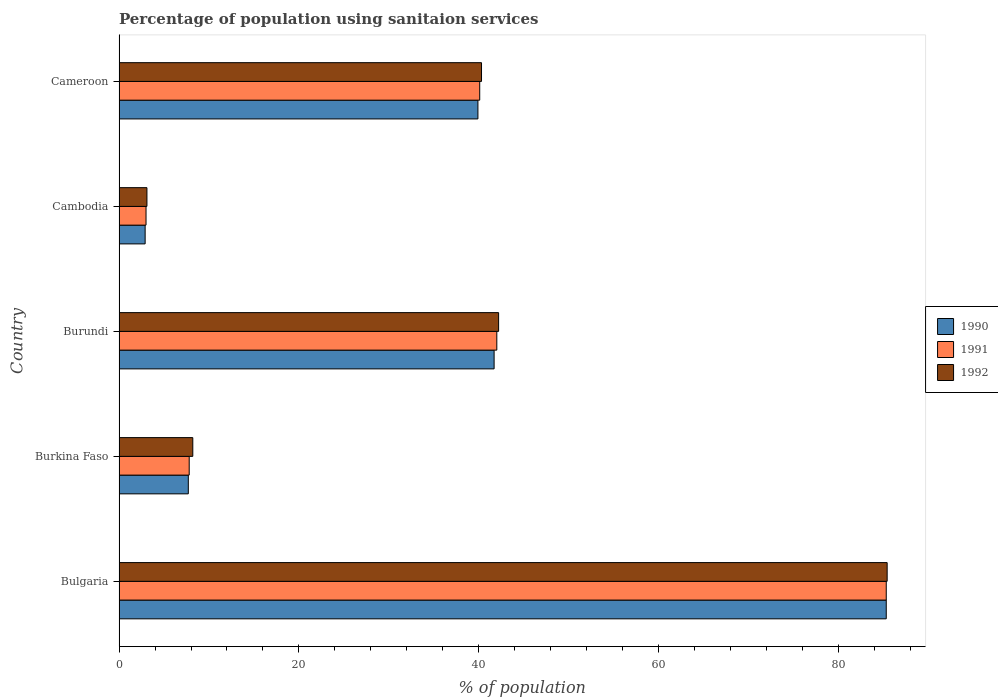How many different coloured bars are there?
Your answer should be compact. 3. How many groups of bars are there?
Your answer should be compact. 5. Are the number of bars per tick equal to the number of legend labels?
Offer a very short reply. Yes. Are the number of bars on each tick of the Y-axis equal?
Offer a terse response. Yes. What is the label of the 2nd group of bars from the top?
Provide a succinct answer. Cambodia. What is the percentage of population using sanitaion services in 1990 in Burundi?
Offer a very short reply. 41.7. Across all countries, what is the maximum percentage of population using sanitaion services in 1990?
Your response must be concise. 85.3. In which country was the percentage of population using sanitaion services in 1991 maximum?
Ensure brevity in your answer.  Bulgaria. In which country was the percentage of population using sanitaion services in 1990 minimum?
Provide a succinct answer. Cambodia. What is the total percentage of population using sanitaion services in 1990 in the graph?
Ensure brevity in your answer.  177.5. What is the difference between the percentage of population using sanitaion services in 1990 in Cambodia and that in Cameroon?
Make the answer very short. -37. What is the difference between the percentage of population using sanitaion services in 1991 in Burkina Faso and the percentage of population using sanitaion services in 1992 in Bulgaria?
Provide a succinct answer. -77.6. What is the average percentage of population using sanitaion services in 1990 per country?
Provide a succinct answer. 35.5. What is the difference between the percentage of population using sanitaion services in 1990 and percentage of population using sanitaion services in 1991 in Cambodia?
Your answer should be compact. -0.1. In how many countries, is the percentage of population using sanitaion services in 1991 greater than 72 %?
Provide a short and direct response. 1. What is the ratio of the percentage of population using sanitaion services in 1992 in Burkina Faso to that in Burundi?
Give a very brief answer. 0.19. Is the percentage of population using sanitaion services in 1991 in Bulgaria less than that in Burkina Faso?
Your answer should be compact. No. What is the difference between the highest and the second highest percentage of population using sanitaion services in 1991?
Offer a terse response. 43.3. What is the difference between the highest and the lowest percentage of population using sanitaion services in 1991?
Give a very brief answer. 82.3. In how many countries, is the percentage of population using sanitaion services in 1992 greater than the average percentage of population using sanitaion services in 1992 taken over all countries?
Ensure brevity in your answer.  3. What does the 3rd bar from the top in Burkina Faso represents?
Give a very brief answer. 1990. Is it the case that in every country, the sum of the percentage of population using sanitaion services in 1990 and percentage of population using sanitaion services in 1992 is greater than the percentage of population using sanitaion services in 1991?
Keep it short and to the point. Yes. How many bars are there?
Provide a short and direct response. 15. Are all the bars in the graph horizontal?
Your answer should be compact. Yes. How many countries are there in the graph?
Make the answer very short. 5. Does the graph contain any zero values?
Give a very brief answer. No. Does the graph contain grids?
Your response must be concise. No. Where does the legend appear in the graph?
Provide a succinct answer. Center right. How many legend labels are there?
Offer a terse response. 3. How are the legend labels stacked?
Your answer should be very brief. Vertical. What is the title of the graph?
Provide a succinct answer. Percentage of population using sanitaion services. Does "1978" appear as one of the legend labels in the graph?
Offer a very short reply. No. What is the label or title of the X-axis?
Your answer should be very brief. % of population. What is the % of population of 1990 in Bulgaria?
Your answer should be very brief. 85.3. What is the % of population of 1991 in Bulgaria?
Ensure brevity in your answer.  85.3. What is the % of population of 1992 in Bulgaria?
Make the answer very short. 85.4. What is the % of population in 1992 in Burkina Faso?
Give a very brief answer. 8.2. What is the % of population in 1990 in Burundi?
Make the answer very short. 41.7. What is the % of population in 1992 in Burundi?
Offer a very short reply. 42.2. What is the % of population in 1991 in Cambodia?
Your answer should be very brief. 3. What is the % of population of 1992 in Cambodia?
Offer a terse response. 3.1. What is the % of population in 1990 in Cameroon?
Your answer should be very brief. 39.9. What is the % of population in 1991 in Cameroon?
Your answer should be compact. 40.1. What is the % of population of 1992 in Cameroon?
Your answer should be very brief. 40.3. Across all countries, what is the maximum % of population in 1990?
Keep it short and to the point. 85.3. Across all countries, what is the maximum % of population of 1991?
Your answer should be very brief. 85.3. Across all countries, what is the maximum % of population in 1992?
Your answer should be compact. 85.4. Across all countries, what is the minimum % of population in 1990?
Your answer should be very brief. 2.9. Across all countries, what is the minimum % of population in 1992?
Provide a short and direct response. 3.1. What is the total % of population of 1990 in the graph?
Offer a very short reply. 177.5. What is the total % of population in 1991 in the graph?
Provide a succinct answer. 178.2. What is the total % of population of 1992 in the graph?
Ensure brevity in your answer.  179.2. What is the difference between the % of population in 1990 in Bulgaria and that in Burkina Faso?
Provide a succinct answer. 77.6. What is the difference between the % of population of 1991 in Bulgaria and that in Burkina Faso?
Make the answer very short. 77.5. What is the difference between the % of population in 1992 in Bulgaria and that in Burkina Faso?
Your answer should be compact. 77.2. What is the difference between the % of population of 1990 in Bulgaria and that in Burundi?
Offer a terse response. 43.6. What is the difference between the % of population in 1991 in Bulgaria and that in Burundi?
Your answer should be very brief. 43.3. What is the difference between the % of population in 1992 in Bulgaria and that in Burundi?
Offer a terse response. 43.2. What is the difference between the % of population of 1990 in Bulgaria and that in Cambodia?
Your response must be concise. 82.4. What is the difference between the % of population in 1991 in Bulgaria and that in Cambodia?
Keep it short and to the point. 82.3. What is the difference between the % of population in 1992 in Bulgaria and that in Cambodia?
Ensure brevity in your answer.  82.3. What is the difference between the % of population of 1990 in Bulgaria and that in Cameroon?
Make the answer very short. 45.4. What is the difference between the % of population of 1991 in Bulgaria and that in Cameroon?
Keep it short and to the point. 45.2. What is the difference between the % of population in 1992 in Bulgaria and that in Cameroon?
Ensure brevity in your answer.  45.1. What is the difference between the % of population of 1990 in Burkina Faso and that in Burundi?
Offer a terse response. -34. What is the difference between the % of population in 1991 in Burkina Faso and that in Burundi?
Your answer should be very brief. -34.2. What is the difference between the % of population of 1992 in Burkina Faso and that in Burundi?
Your answer should be compact. -34. What is the difference between the % of population in 1991 in Burkina Faso and that in Cambodia?
Keep it short and to the point. 4.8. What is the difference between the % of population in 1992 in Burkina Faso and that in Cambodia?
Make the answer very short. 5.1. What is the difference between the % of population in 1990 in Burkina Faso and that in Cameroon?
Offer a very short reply. -32.2. What is the difference between the % of population of 1991 in Burkina Faso and that in Cameroon?
Your answer should be very brief. -32.3. What is the difference between the % of population of 1992 in Burkina Faso and that in Cameroon?
Your answer should be very brief. -32.1. What is the difference between the % of population of 1990 in Burundi and that in Cambodia?
Provide a succinct answer. 38.8. What is the difference between the % of population in 1991 in Burundi and that in Cambodia?
Your answer should be very brief. 39. What is the difference between the % of population in 1992 in Burundi and that in Cambodia?
Your answer should be very brief. 39.1. What is the difference between the % of population of 1990 in Burundi and that in Cameroon?
Your response must be concise. 1.8. What is the difference between the % of population in 1992 in Burundi and that in Cameroon?
Your answer should be very brief. 1.9. What is the difference between the % of population in 1990 in Cambodia and that in Cameroon?
Your answer should be very brief. -37. What is the difference between the % of population of 1991 in Cambodia and that in Cameroon?
Your response must be concise. -37.1. What is the difference between the % of population of 1992 in Cambodia and that in Cameroon?
Make the answer very short. -37.2. What is the difference between the % of population in 1990 in Bulgaria and the % of population in 1991 in Burkina Faso?
Your answer should be compact. 77.5. What is the difference between the % of population in 1990 in Bulgaria and the % of population in 1992 in Burkina Faso?
Ensure brevity in your answer.  77.1. What is the difference between the % of population in 1991 in Bulgaria and the % of population in 1992 in Burkina Faso?
Provide a succinct answer. 77.1. What is the difference between the % of population in 1990 in Bulgaria and the % of population in 1991 in Burundi?
Offer a very short reply. 43.3. What is the difference between the % of population of 1990 in Bulgaria and the % of population of 1992 in Burundi?
Keep it short and to the point. 43.1. What is the difference between the % of population in 1991 in Bulgaria and the % of population in 1992 in Burundi?
Offer a very short reply. 43.1. What is the difference between the % of population of 1990 in Bulgaria and the % of population of 1991 in Cambodia?
Provide a short and direct response. 82.3. What is the difference between the % of population of 1990 in Bulgaria and the % of population of 1992 in Cambodia?
Offer a very short reply. 82.2. What is the difference between the % of population in 1991 in Bulgaria and the % of population in 1992 in Cambodia?
Keep it short and to the point. 82.2. What is the difference between the % of population of 1990 in Bulgaria and the % of population of 1991 in Cameroon?
Your answer should be compact. 45.2. What is the difference between the % of population of 1990 in Burkina Faso and the % of population of 1991 in Burundi?
Offer a terse response. -34.3. What is the difference between the % of population in 1990 in Burkina Faso and the % of population in 1992 in Burundi?
Your response must be concise. -34.5. What is the difference between the % of population in 1991 in Burkina Faso and the % of population in 1992 in Burundi?
Provide a short and direct response. -34.4. What is the difference between the % of population in 1990 in Burkina Faso and the % of population in 1991 in Cambodia?
Provide a short and direct response. 4.7. What is the difference between the % of population in 1990 in Burkina Faso and the % of population in 1992 in Cambodia?
Ensure brevity in your answer.  4.6. What is the difference between the % of population of 1990 in Burkina Faso and the % of population of 1991 in Cameroon?
Keep it short and to the point. -32.4. What is the difference between the % of population in 1990 in Burkina Faso and the % of population in 1992 in Cameroon?
Offer a terse response. -32.6. What is the difference between the % of population of 1991 in Burkina Faso and the % of population of 1992 in Cameroon?
Your response must be concise. -32.5. What is the difference between the % of population in 1990 in Burundi and the % of population in 1991 in Cambodia?
Your answer should be very brief. 38.7. What is the difference between the % of population of 1990 in Burundi and the % of population of 1992 in Cambodia?
Provide a succinct answer. 38.6. What is the difference between the % of population in 1991 in Burundi and the % of population in 1992 in Cambodia?
Make the answer very short. 38.9. What is the difference between the % of population in 1990 in Cambodia and the % of population in 1991 in Cameroon?
Keep it short and to the point. -37.2. What is the difference between the % of population of 1990 in Cambodia and the % of population of 1992 in Cameroon?
Offer a very short reply. -37.4. What is the difference between the % of population in 1991 in Cambodia and the % of population in 1992 in Cameroon?
Make the answer very short. -37.3. What is the average % of population of 1990 per country?
Make the answer very short. 35.5. What is the average % of population of 1991 per country?
Ensure brevity in your answer.  35.64. What is the average % of population of 1992 per country?
Your answer should be very brief. 35.84. What is the difference between the % of population of 1991 and % of population of 1992 in Bulgaria?
Ensure brevity in your answer.  -0.1. What is the difference between the % of population of 1990 and % of population of 1991 in Burkina Faso?
Provide a succinct answer. -0.1. What is the difference between the % of population of 1990 and % of population of 1992 in Burkina Faso?
Make the answer very short. -0.5. What is the difference between the % of population of 1991 and % of population of 1992 in Burkina Faso?
Your answer should be compact. -0.4. What is the difference between the % of population in 1990 and % of population in 1991 in Burundi?
Make the answer very short. -0.3. What is the difference between the % of population of 1990 and % of population of 1992 in Burundi?
Your response must be concise. -0.5. What is the difference between the % of population in 1990 and % of population in 1991 in Cambodia?
Provide a short and direct response. -0.1. What is the difference between the % of population of 1991 and % of population of 1992 in Cambodia?
Your answer should be very brief. -0.1. What is the difference between the % of population in 1990 and % of population in 1991 in Cameroon?
Provide a short and direct response. -0.2. What is the difference between the % of population of 1991 and % of population of 1992 in Cameroon?
Make the answer very short. -0.2. What is the ratio of the % of population in 1990 in Bulgaria to that in Burkina Faso?
Your answer should be very brief. 11.08. What is the ratio of the % of population of 1991 in Bulgaria to that in Burkina Faso?
Offer a very short reply. 10.94. What is the ratio of the % of population of 1992 in Bulgaria to that in Burkina Faso?
Your response must be concise. 10.41. What is the ratio of the % of population in 1990 in Bulgaria to that in Burundi?
Provide a short and direct response. 2.05. What is the ratio of the % of population of 1991 in Bulgaria to that in Burundi?
Keep it short and to the point. 2.03. What is the ratio of the % of population of 1992 in Bulgaria to that in Burundi?
Provide a succinct answer. 2.02. What is the ratio of the % of population of 1990 in Bulgaria to that in Cambodia?
Make the answer very short. 29.41. What is the ratio of the % of population of 1991 in Bulgaria to that in Cambodia?
Provide a short and direct response. 28.43. What is the ratio of the % of population in 1992 in Bulgaria to that in Cambodia?
Offer a very short reply. 27.55. What is the ratio of the % of population in 1990 in Bulgaria to that in Cameroon?
Ensure brevity in your answer.  2.14. What is the ratio of the % of population of 1991 in Bulgaria to that in Cameroon?
Give a very brief answer. 2.13. What is the ratio of the % of population of 1992 in Bulgaria to that in Cameroon?
Your response must be concise. 2.12. What is the ratio of the % of population in 1990 in Burkina Faso to that in Burundi?
Offer a very short reply. 0.18. What is the ratio of the % of population in 1991 in Burkina Faso to that in Burundi?
Your answer should be very brief. 0.19. What is the ratio of the % of population in 1992 in Burkina Faso to that in Burundi?
Your answer should be compact. 0.19. What is the ratio of the % of population of 1990 in Burkina Faso to that in Cambodia?
Ensure brevity in your answer.  2.66. What is the ratio of the % of population in 1992 in Burkina Faso to that in Cambodia?
Ensure brevity in your answer.  2.65. What is the ratio of the % of population of 1990 in Burkina Faso to that in Cameroon?
Ensure brevity in your answer.  0.19. What is the ratio of the % of population of 1991 in Burkina Faso to that in Cameroon?
Give a very brief answer. 0.19. What is the ratio of the % of population in 1992 in Burkina Faso to that in Cameroon?
Keep it short and to the point. 0.2. What is the ratio of the % of population in 1990 in Burundi to that in Cambodia?
Offer a terse response. 14.38. What is the ratio of the % of population in 1991 in Burundi to that in Cambodia?
Give a very brief answer. 14. What is the ratio of the % of population in 1992 in Burundi to that in Cambodia?
Your response must be concise. 13.61. What is the ratio of the % of population of 1990 in Burundi to that in Cameroon?
Ensure brevity in your answer.  1.05. What is the ratio of the % of population of 1991 in Burundi to that in Cameroon?
Give a very brief answer. 1.05. What is the ratio of the % of population in 1992 in Burundi to that in Cameroon?
Your answer should be very brief. 1.05. What is the ratio of the % of population in 1990 in Cambodia to that in Cameroon?
Offer a very short reply. 0.07. What is the ratio of the % of population in 1991 in Cambodia to that in Cameroon?
Keep it short and to the point. 0.07. What is the ratio of the % of population in 1992 in Cambodia to that in Cameroon?
Offer a terse response. 0.08. What is the difference between the highest and the second highest % of population in 1990?
Keep it short and to the point. 43.6. What is the difference between the highest and the second highest % of population in 1991?
Offer a terse response. 43.3. What is the difference between the highest and the second highest % of population in 1992?
Keep it short and to the point. 43.2. What is the difference between the highest and the lowest % of population in 1990?
Your answer should be compact. 82.4. What is the difference between the highest and the lowest % of population in 1991?
Ensure brevity in your answer.  82.3. What is the difference between the highest and the lowest % of population in 1992?
Offer a very short reply. 82.3. 